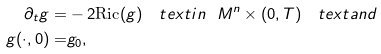<formula> <loc_0><loc_0><loc_500><loc_500>\partial _ { t } g = & - 2 \text {Ric} ( g ) \quad t e x t { i n } \ \ M ^ { n } \times ( 0 , T ) \quad t e x t { a n d } \\ g ( \cdot , 0 ) = & g _ { 0 } ,</formula> 